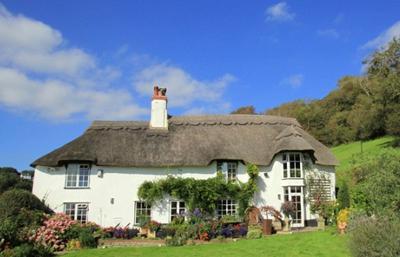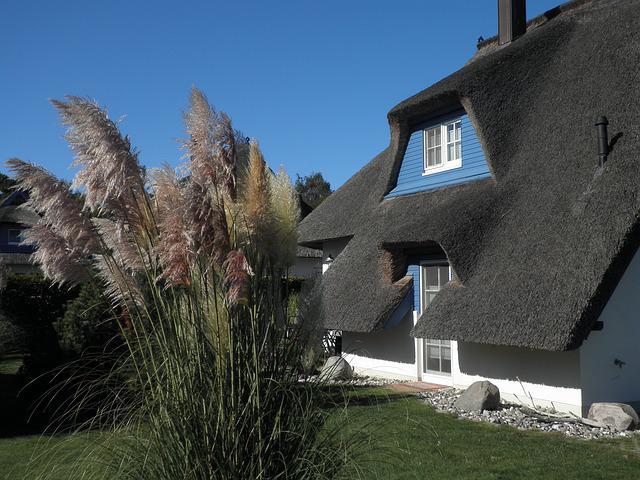The first image is the image on the left, the second image is the image on the right. Evaluate the accuracy of this statement regarding the images: "A short stone wall bounds the house in the image on the left.". Is it true? Answer yes or no. No. The first image is the image on the left, the second image is the image on the right. Considering the images on both sides, is "In each image, a building has a gray roof that curves around items like windows or doors instead of just overhanging them." valid? Answer yes or no. Yes. 